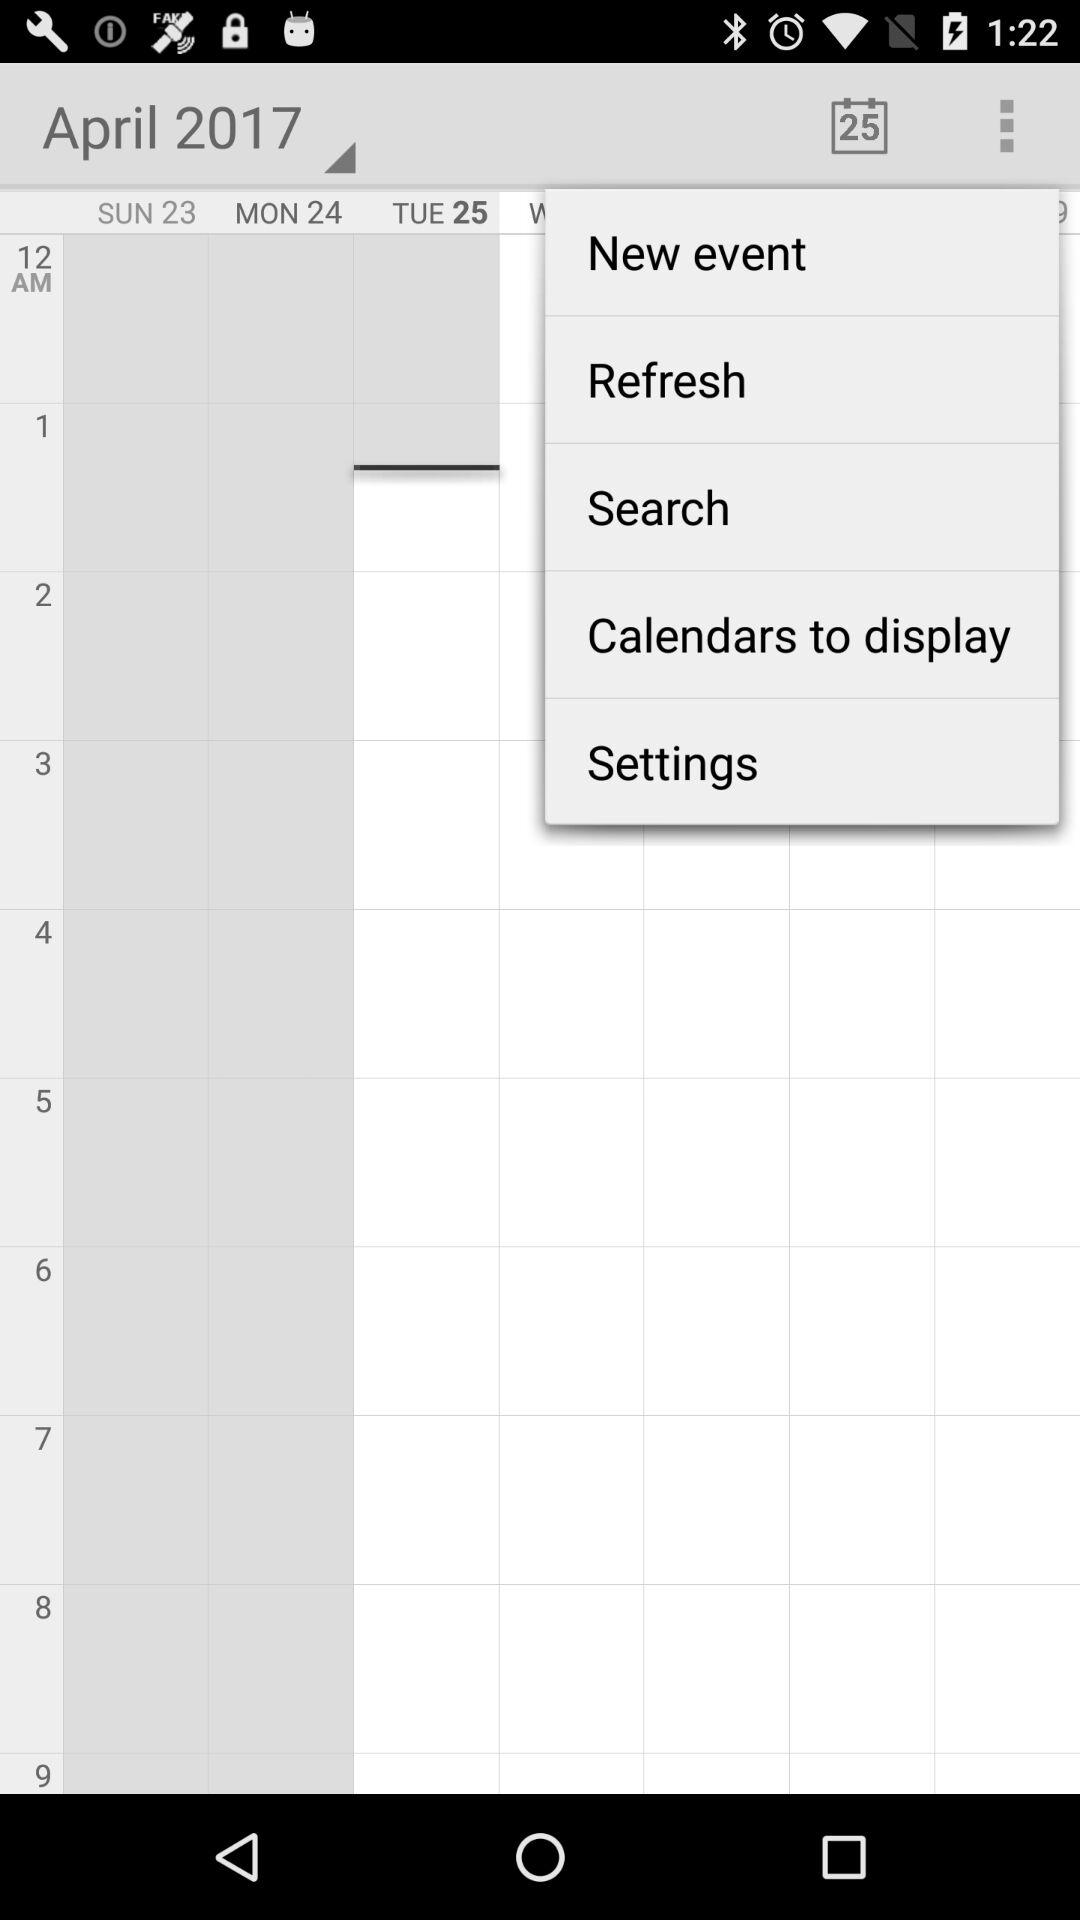Which month is selected? The selected month is "April". 